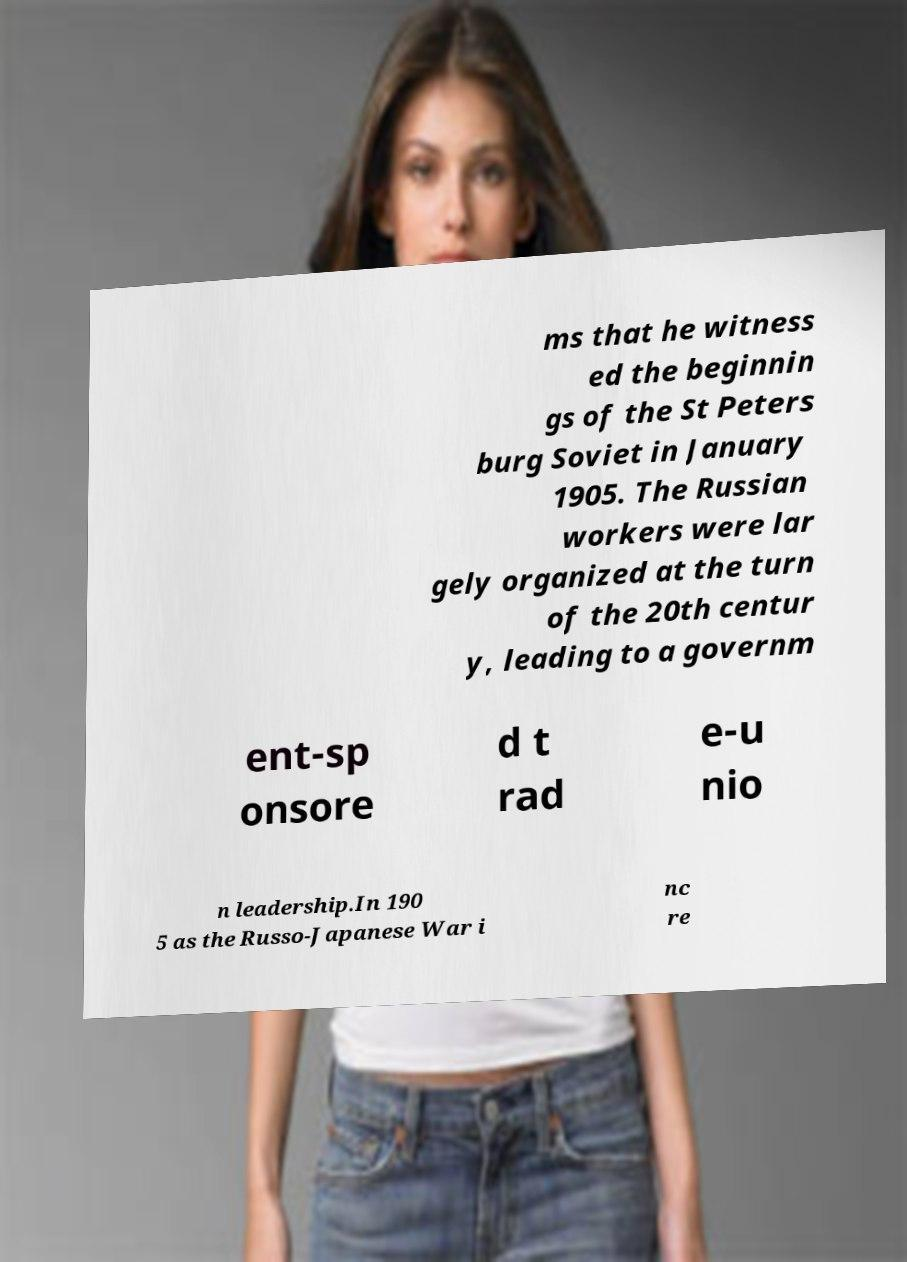Can you read and provide the text displayed in the image?This photo seems to have some interesting text. Can you extract and type it out for me? ms that he witness ed the beginnin gs of the St Peters burg Soviet in January 1905. The Russian workers were lar gely organized at the turn of the 20th centur y, leading to a governm ent-sp onsore d t rad e-u nio n leadership.In 190 5 as the Russo-Japanese War i nc re 